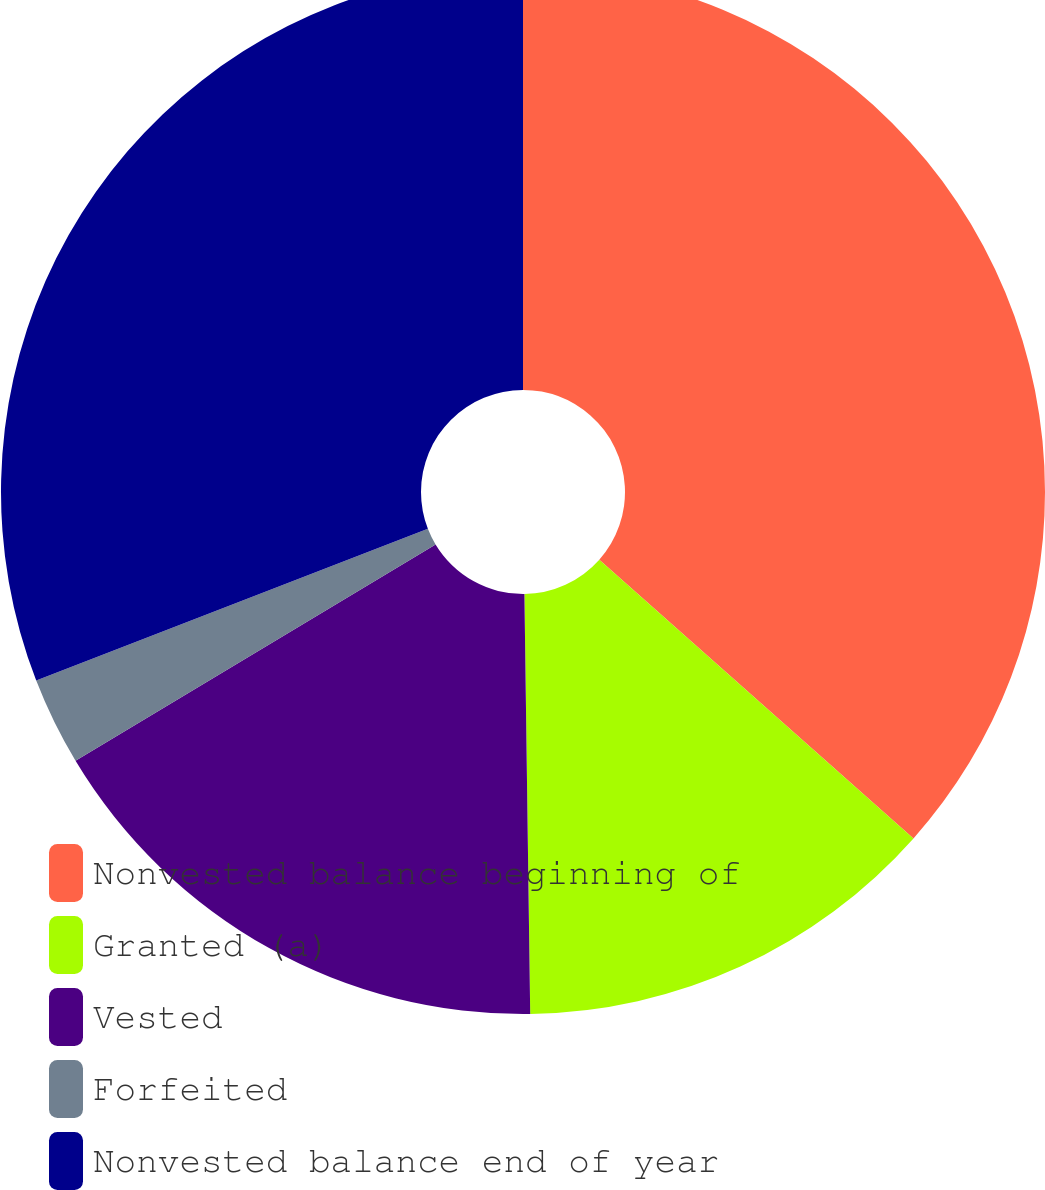Convert chart to OTSL. <chart><loc_0><loc_0><loc_500><loc_500><pie_chart><fcel>Nonvested balance beginning of<fcel>Granted (a)<fcel>Vested<fcel>Forfeited<fcel>Nonvested balance end of year<nl><fcel>36.55%<fcel>13.23%<fcel>16.61%<fcel>2.73%<fcel>30.88%<nl></chart> 